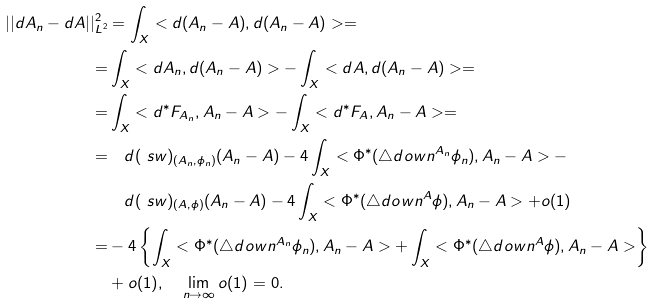<formula> <loc_0><loc_0><loc_500><loc_500>| | d A _ { n } - d A | | ^ { 2 } _ { L ^ { 2 } } & = \int _ { X } < d ( A _ { n } - A ) , d ( A _ { n } - A ) > = \\ = & \int _ { X } < d A _ { n } , d ( A _ { n } - A ) > - \int _ { X } < d A , d ( A _ { n } - A ) > = \\ = & \int _ { X } < d ^ { * } F _ { A _ { n } } , A _ { n } - A > - \int _ { X } < d ^ { * } F _ { A } , A _ { n } - A > = \\ = & \quad d ( \ s w ) _ { ( A _ { n } , \phi _ { n } ) } ( A _ { n } - A ) - 4 \int _ { X } < \Phi ^ { * } ( \triangle d o w n ^ { A _ { n } } \phi _ { n } ) , A _ { n } - A > - \\ & \quad d ( \ s w ) _ { ( A , \phi ) } ( A _ { n } - A ) - 4 \int _ { X } < \Phi ^ { * } ( \triangle d o w n ^ { A } \phi ) , A _ { n } - A > + o ( 1 ) \\ = & - 4 \left \{ \int _ { X } < \Phi ^ { * } ( \triangle d o w n ^ { A _ { n } } \phi _ { n } ) , A _ { n } - A > + \int _ { X } < \Phi ^ { * } ( \triangle d o w n ^ { A } \phi ) , A _ { n } - A > \right \} \\ & + o ( 1 ) , \quad \lim _ { n \to \infty } o ( 1 ) = 0 .</formula> 